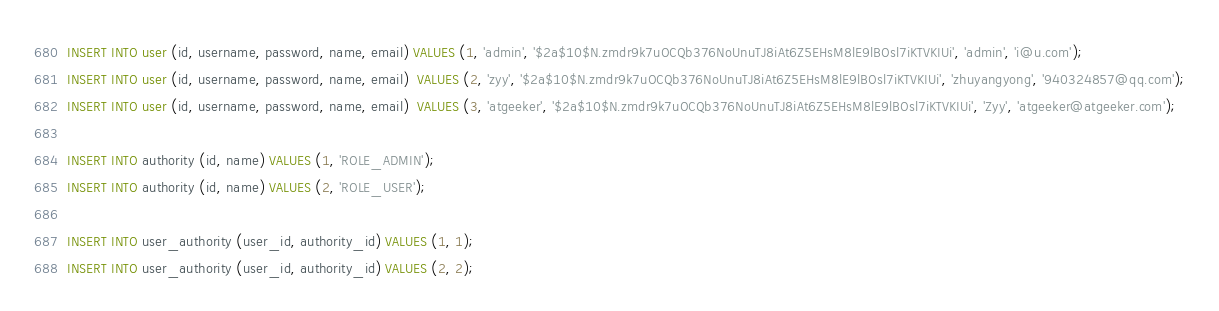<code> <loc_0><loc_0><loc_500><loc_500><_SQL_>INSERT INTO user (id, username, password, name, email) VALUES (1, 'admin', '$2a$10$N.zmdr9k7uOCQb376NoUnuTJ8iAt6Z5EHsM8lE9lBOsl7iKTVKIUi', 'admin', 'i@u.com');
INSERT INTO user (id, username, password, name, email)  VALUES (2, 'zyy', '$2a$10$N.zmdr9k7uOCQb376NoUnuTJ8iAt6Z5EHsM8lE9lBOsl7iKTVKIUi', 'zhuyangyong', '940324857@qq.com');
INSERT INTO user (id, username, password, name, email)  VALUES (3, 'atgeeker', '$2a$10$N.zmdr9k7uOCQb376NoUnuTJ8iAt6Z5EHsM8lE9lBOsl7iKTVKIUi', 'Zyy', 'atgeeker@atgeeker.com');

INSERT INTO authority (id, name) VALUES (1, 'ROLE_ADMIN');
INSERT INTO authority (id, name) VALUES (2, 'ROLE_USER');

INSERT INTO user_authority (user_id, authority_id) VALUES (1, 1);
INSERT INTO user_authority (user_id, authority_id) VALUES (2, 2);
</code> 